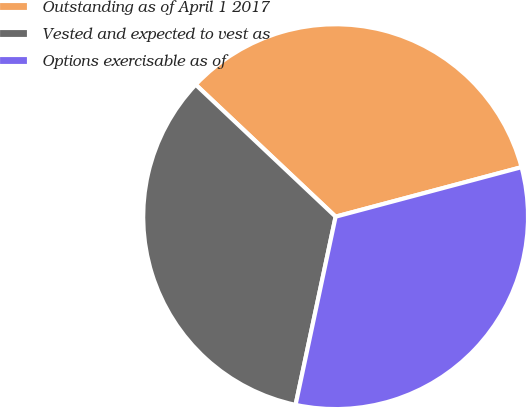Convert chart to OTSL. <chart><loc_0><loc_0><loc_500><loc_500><pie_chart><fcel>Outstanding as of April 1 2017<fcel>Vested and expected to vest as<fcel>Options exercisable as of<nl><fcel>33.82%<fcel>33.7%<fcel>32.48%<nl></chart> 